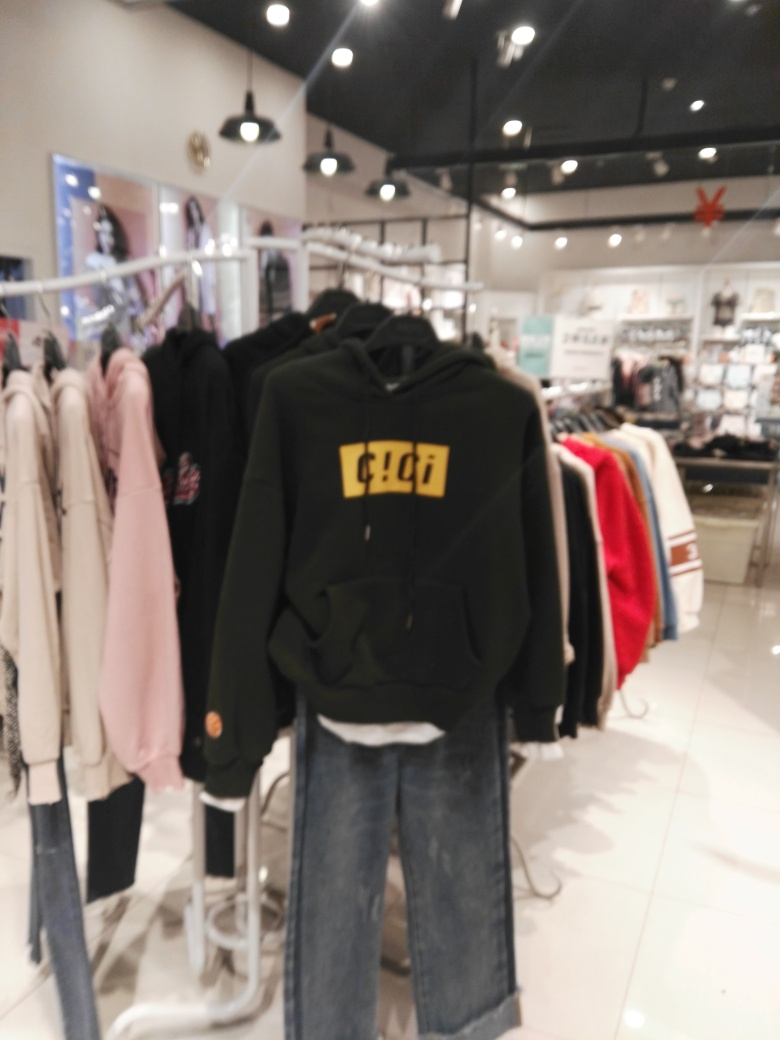Can you provide a description of the clothing items visible in the image? The image displays a variety of clothing items in a retail setting. In the foreground, there's a black hoodie with bright yellow numbers reading '91', hanging on a rack. Behind it, there appears to be a mix of other garments including light pink and white tops. Due to the image's blurriness, specific details about the styles and textures are indiscernible. What do you think the numbers '91' on the hoodie represent? It's difficult to determine the exact significance of the number '91' without additional context, but it could represent a year of importance, a sports jersey number, part of a branding element, or simply a design choice with no intended meaning beyond aesthetics. 